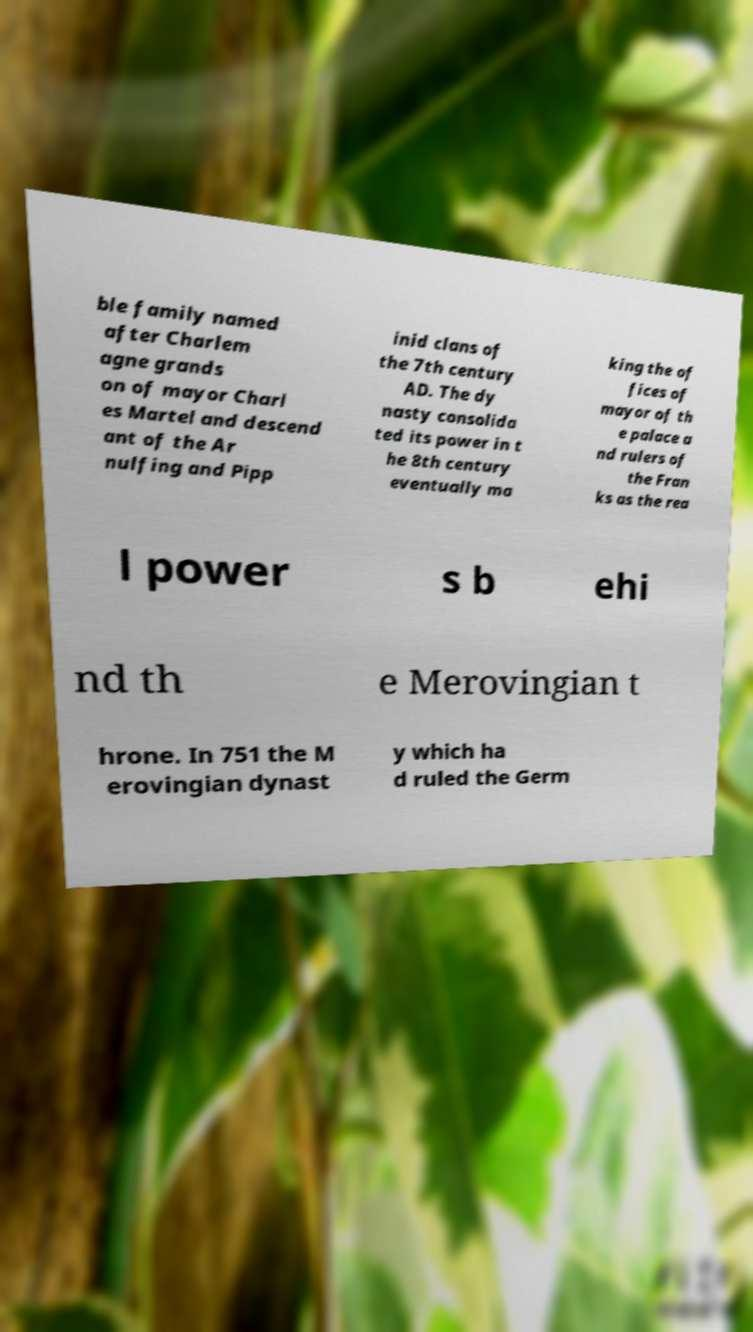Please identify and transcribe the text found in this image. ble family named after Charlem agne grands on of mayor Charl es Martel and descend ant of the Ar nulfing and Pipp inid clans of the 7th century AD. The dy nasty consolida ted its power in t he 8th century eventually ma king the of fices of mayor of th e palace a nd rulers of the Fran ks as the rea l power s b ehi nd th e Merovingian t hrone. In 751 the M erovingian dynast y which ha d ruled the Germ 